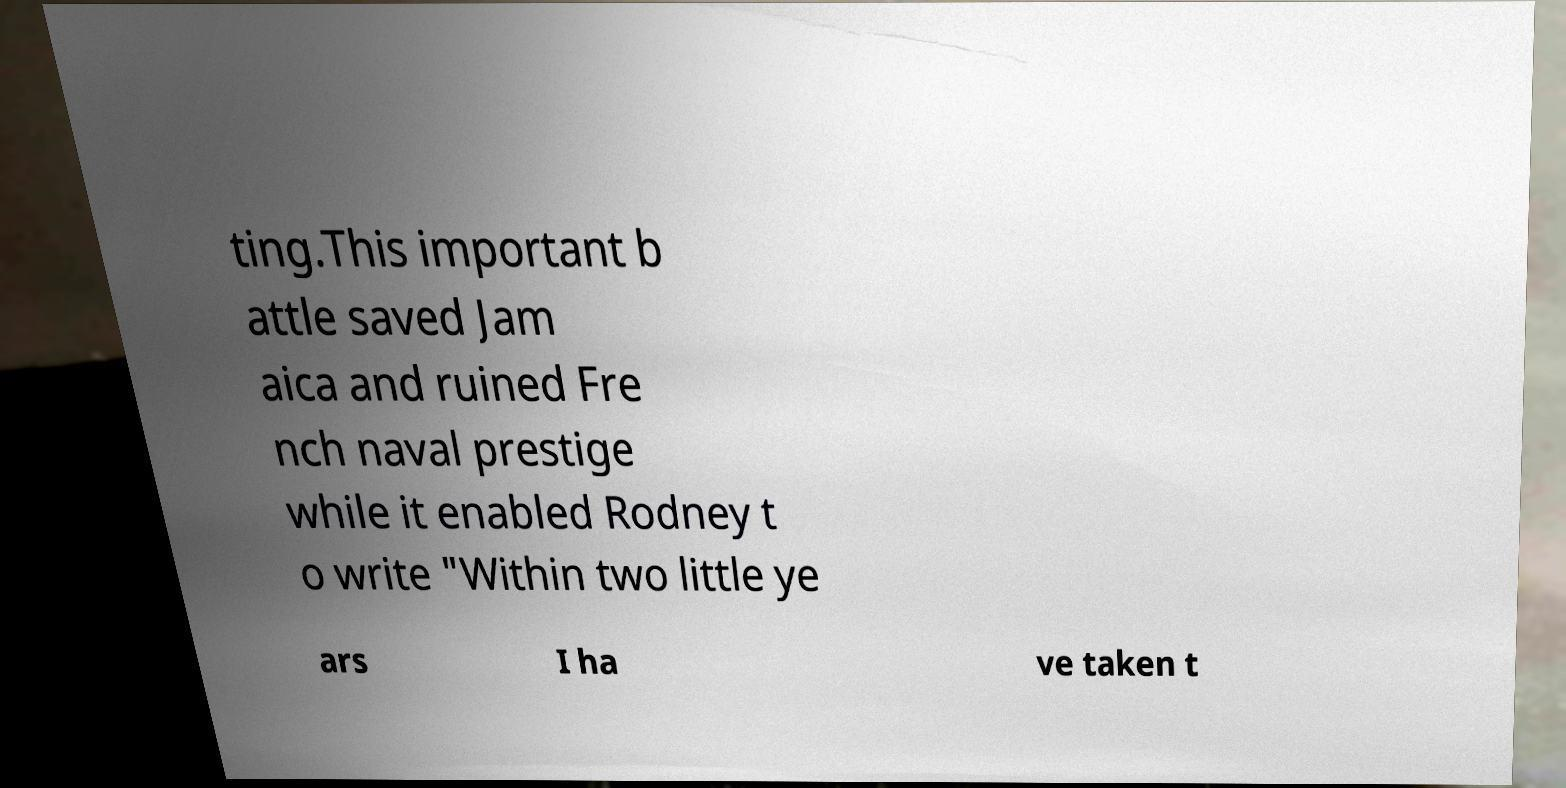There's text embedded in this image that I need extracted. Can you transcribe it verbatim? ting.This important b attle saved Jam aica and ruined Fre nch naval prestige while it enabled Rodney t o write "Within two little ye ars I ha ve taken t 